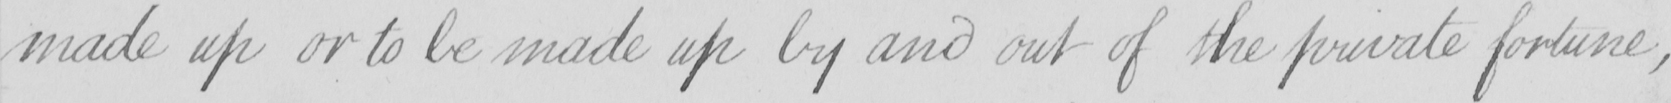Transcribe the text shown in this historical manuscript line. made up or to be made up by and out of the private fortune , 